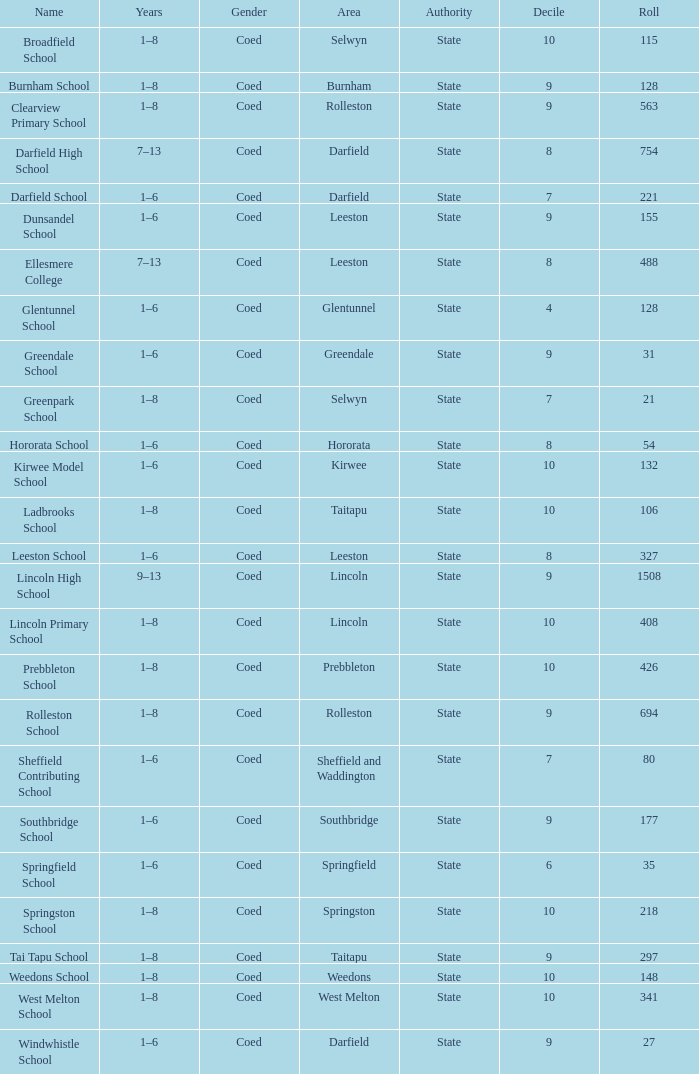What is the name with a decile under 10 and a roll number of 297? Tai Tapu School. 